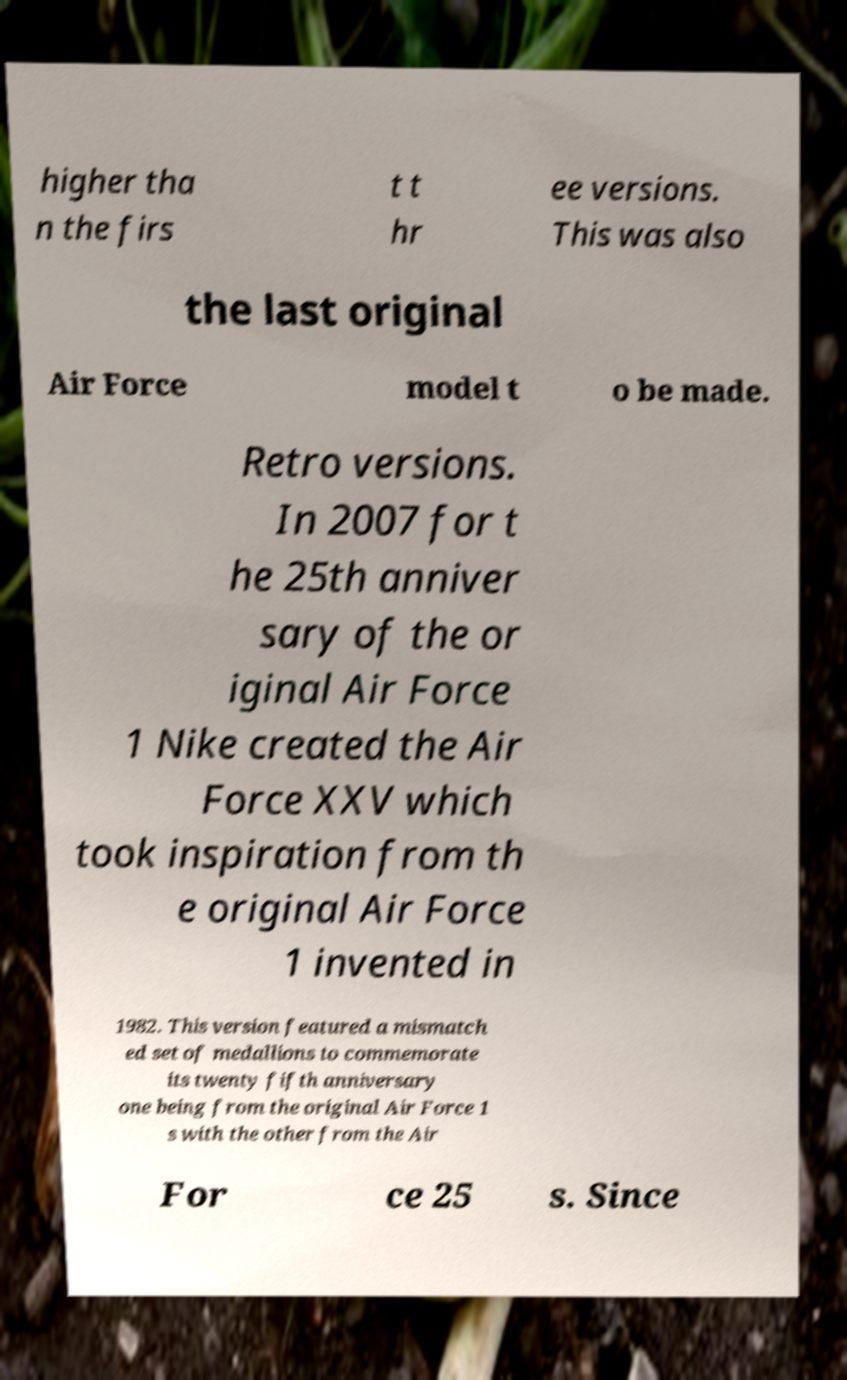Please identify and transcribe the text found in this image. higher tha n the firs t t hr ee versions. This was also the last original Air Force model t o be made. Retro versions. In 2007 for t he 25th anniver sary of the or iginal Air Force 1 Nike created the Air Force XXV which took inspiration from th e original Air Force 1 invented in 1982. This version featured a mismatch ed set of medallions to commemorate its twenty fifth anniversary one being from the original Air Force 1 s with the other from the Air For ce 25 s. Since 